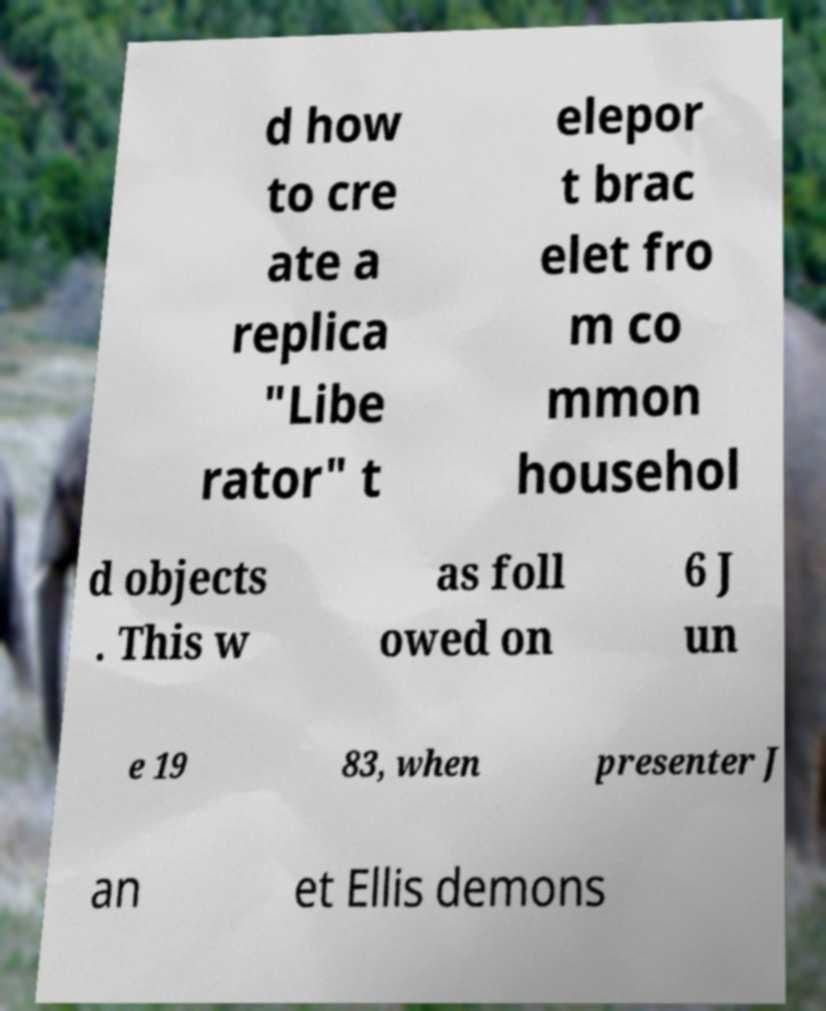What messages or text are displayed in this image? I need them in a readable, typed format. d how to cre ate a replica "Libe rator" t elepor t brac elet fro m co mmon househol d objects . This w as foll owed on 6 J un e 19 83, when presenter J an et Ellis demons 